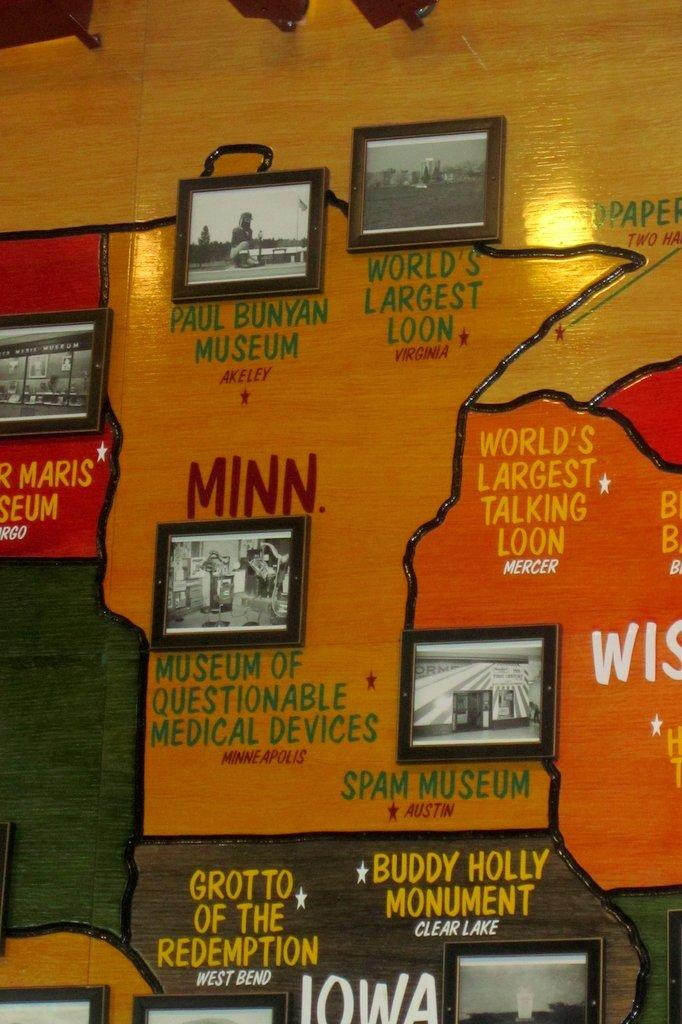<image>
Offer a succinct explanation of the picture presented. A list of odd museums including the Museum of Questionable Medical Devices. 